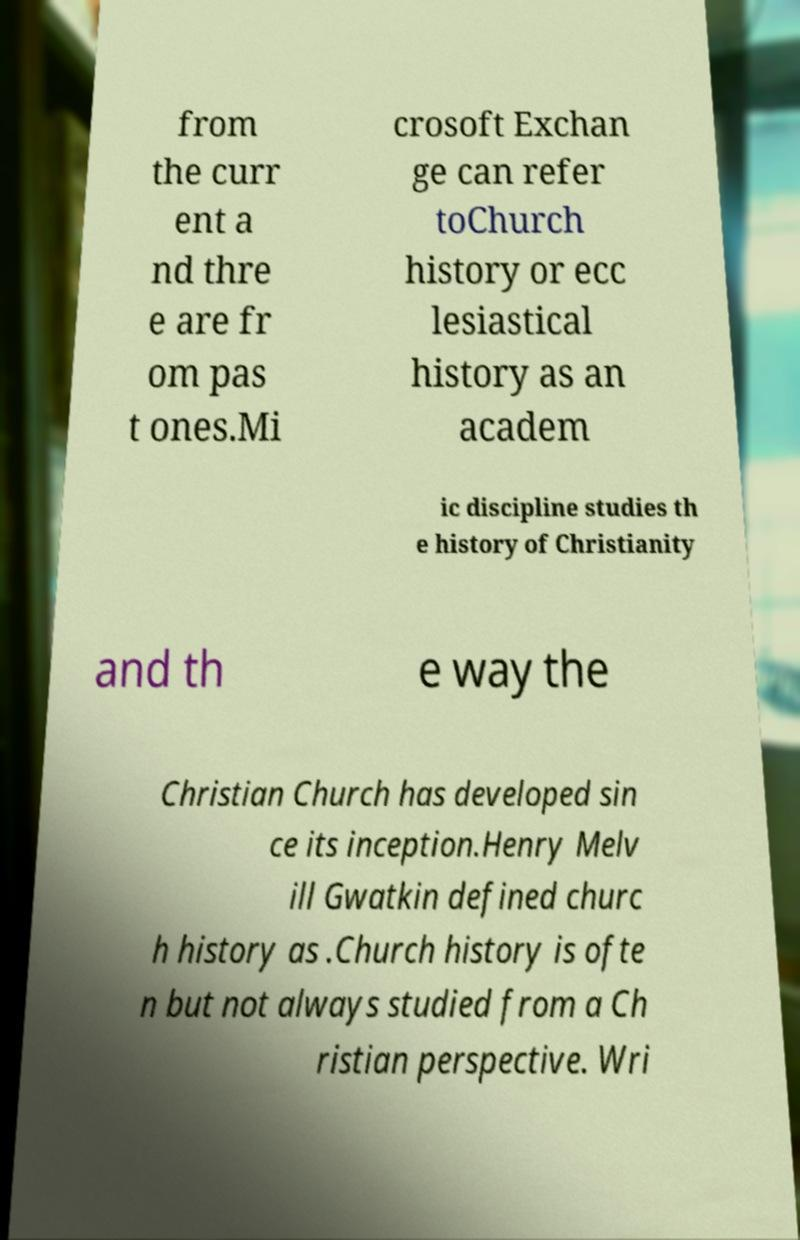Can you accurately transcribe the text from the provided image for me? from the curr ent a nd thre e are fr om pas t ones.Mi crosoft Exchan ge can refer toChurch history or ecc lesiastical history as an academ ic discipline studies th e history of Christianity and th e way the Christian Church has developed sin ce its inception.Henry Melv ill Gwatkin defined churc h history as .Church history is ofte n but not always studied from a Ch ristian perspective. Wri 